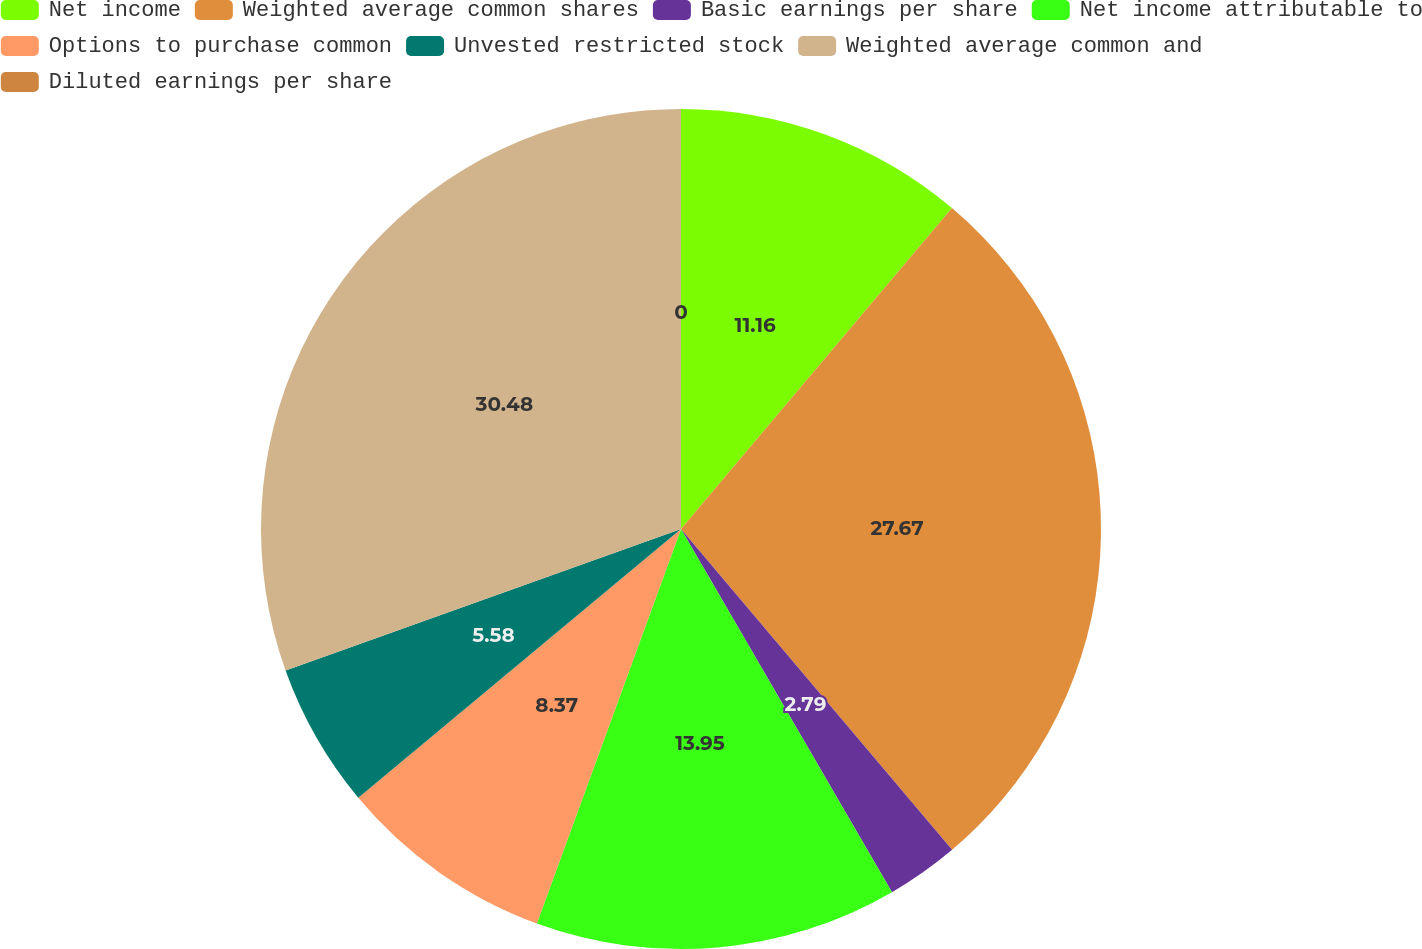<chart> <loc_0><loc_0><loc_500><loc_500><pie_chart><fcel>Net income<fcel>Weighted average common shares<fcel>Basic earnings per share<fcel>Net income attributable to<fcel>Options to purchase common<fcel>Unvested restricted stock<fcel>Weighted average common and<fcel>Diluted earnings per share<nl><fcel>11.16%<fcel>27.67%<fcel>2.79%<fcel>13.95%<fcel>8.37%<fcel>5.58%<fcel>30.47%<fcel>0.0%<nl></chart> 